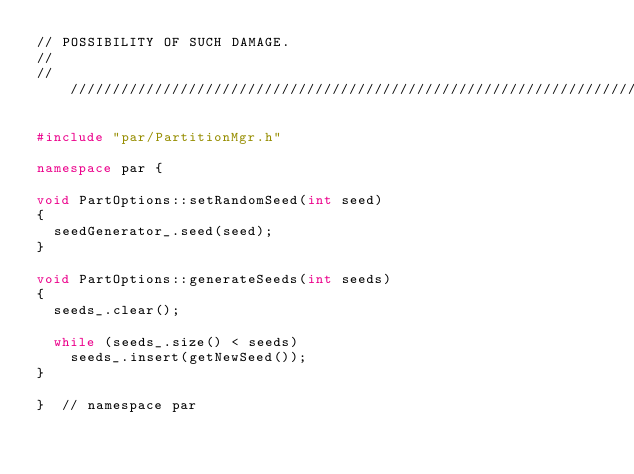Convert code to text. <code><loc_0><loc_0><loc_500><loc_500><_C++_>// POSSIBILITY OF SUCH DAMAGE.
//
///////////////////////////////////////////////////////////////////////////////

#include "par/PartitionMgr.h"

namespace par {

void PartOptions::setRandomSeed(int seed)
{
  seedGenerator_.seed(seed);
}

void PartOptions::generateSeeds(int seeds)
{
  seeds_.clear();

  while (seeds_.size() < seeds)
    seeds_.insert(getNewSeed());
}

}  // namespace par
</code> 